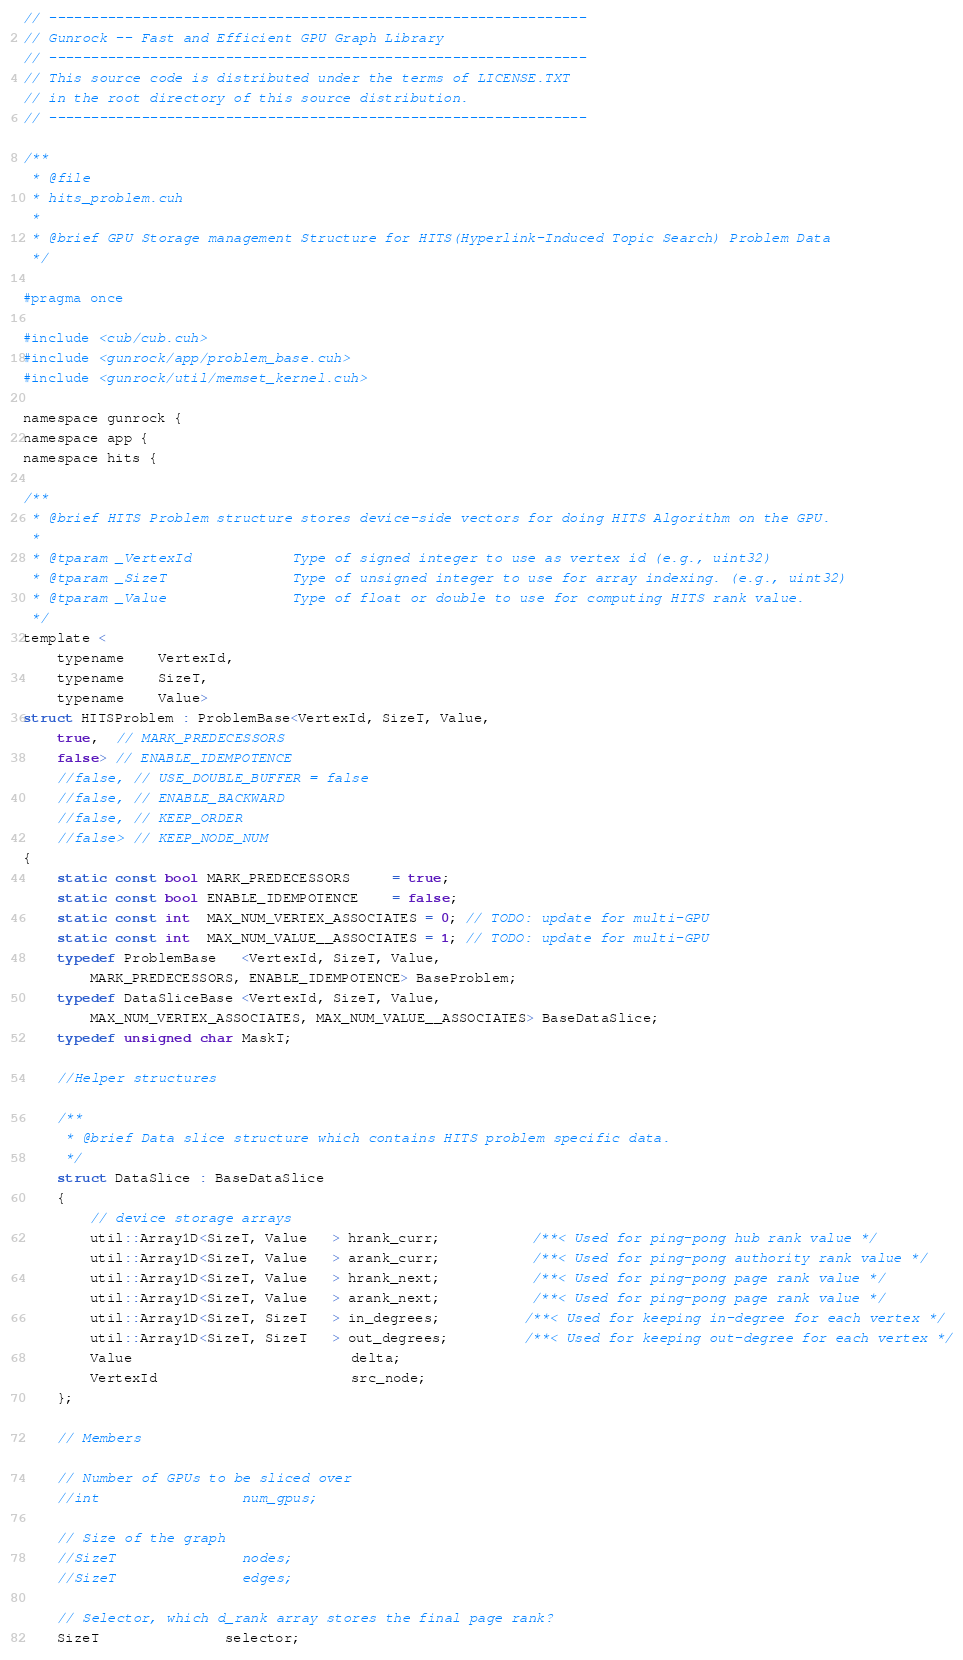Convert code to text. <code><loc_0><loc_0><loc_500><loc_500><_Cuda_>// ----------------------------------------------------------------
// Gunrock -- Fast and Efficient GPU Graph Library
// ----------------------------------------------------------------
// This source code is distributed under the terms of LICENSE.TXT
// in the root directory of this source distribution.
// ----------------------------------------------------------------

/**
 * @file
 * hits_problem.cuh
 *
 * @brief GPU Storage management Structure for HITS(Hyperlink-Induced Topic Search) Problem Data
 */

#pragma once

#include <cub/cub.cuh>
#include <gunrock/app/problem_base.cuh>
#include <gunrock/util/memset_kernel.cuh>

namespace gunrock {
namespace app {
namespace hits {

/**
 * @brief HITS Problem structure stores device-side vectors for doing HITS Algorithm on the GPU.
 *
 * @tparam _VertexId            Type of signed integer to use as vertex id (e.g., uint32)
 * @tparam _SizeT               Type of unsigned integer to use for array indexing. (e.g., uint32)
 * @tparam _Value               Type of float or double to use for computing HITS rank value.
 */
template <
    typename    VertexId,                       
    typename    SizeT,                          
    typename    Value>
struct HITSProblem : ProblemBase<VertexId, SizeT, Value,
    true,  // MARK_PREDECESSORS
    false> // ENABLE_IDEMPOTENCE
    //false, // USE_DOUBLE_BUFFER = false
    //false, // ENABLE_BACKWARD
    //false, // KEEP_ORDER
    //false> // KEEP_NODE_NUM
{
    static const bool MARK_PREDECESSORS     = true;
    static const bool ENABLE_IDEMPOTENCE    = false;
    static const int  MAX_NUM_VERTEX_ASSOCIATES = 0; // TODO: update for multi-GPU  
    static const int  MAX_NUM_VALUE__ASSOCIATES = 1; // TODO: update for multi-GPU
    typedef ProblemBase   <VertexId, SizeT, Value,
        MARK_PREDECESSORS, ENABLE_IDEMPOTENCE> BaseProblem;
    typedef DataSliceBase <VertexId, SizeT, Value,
        MAX_NUM_VERTEX_ASSOCIATES, MAX_NUM_VALUE__ASSOCIATES> BaseDataSlice;
    typedef unsigned char MaskT;

    //Helper structures

    /**
     * @brief Data slice structure which contains HITS problem specific data.
     */
    struct DataSlice : BaseDataSlice
    {
        // device storage arrays
        util::Array1D<SizeT, Value   > hrank_curr;           /**< Used for ping-pong hub rank value */
        util::Array1D<SizeT, Value   > arank_curr;           /**< Used for ping-pong authority rank value */
        util::Array1D<SizeT, Value   > hrank_next;           /**< Used for ping-pong page rank value */       
        util::Array1D<SizeT, Value   > arank_next;           /**< Used for ping-pong page rank value */       
        util::Array1D<SizeT, SizeT   > in_degrees;          /**< Used for keeping in-degree for each vertex */
        util::Array1D<SizeT, SizeT   > out_degrees;         /**< Used for keeping out-degree for each vertex */
        Value                          delta;
        VertexId                       src_node;
    };

    // Members
    
    // Number of GPUs to be sliced over
    //int                 num_gpus;

    // Size of the graph
    //SizeT               nodes;
    //SizeT               edges;

    // Selector, which d_rank array stores the final page rank?
    SizeT               selector;
</code> 